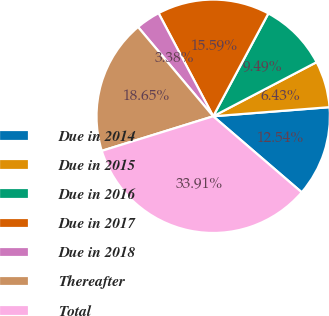<chart> <loc_0><loc_0><loc_500><loc_500><pie_chart><fcel>Due in 2014<fcel>Due in 2015<fcel>Due in 2016<fcel>Due in 2017<fcel>Due in 2018<fcel>Thereafter<fcel>Total<nl><fcel>12.54%<fcel>6.43%<fcel>9.49%<fcel>15.59%<fcel>3.38%<fcel>18.65%<fcel>33.91%<nl></chart> 